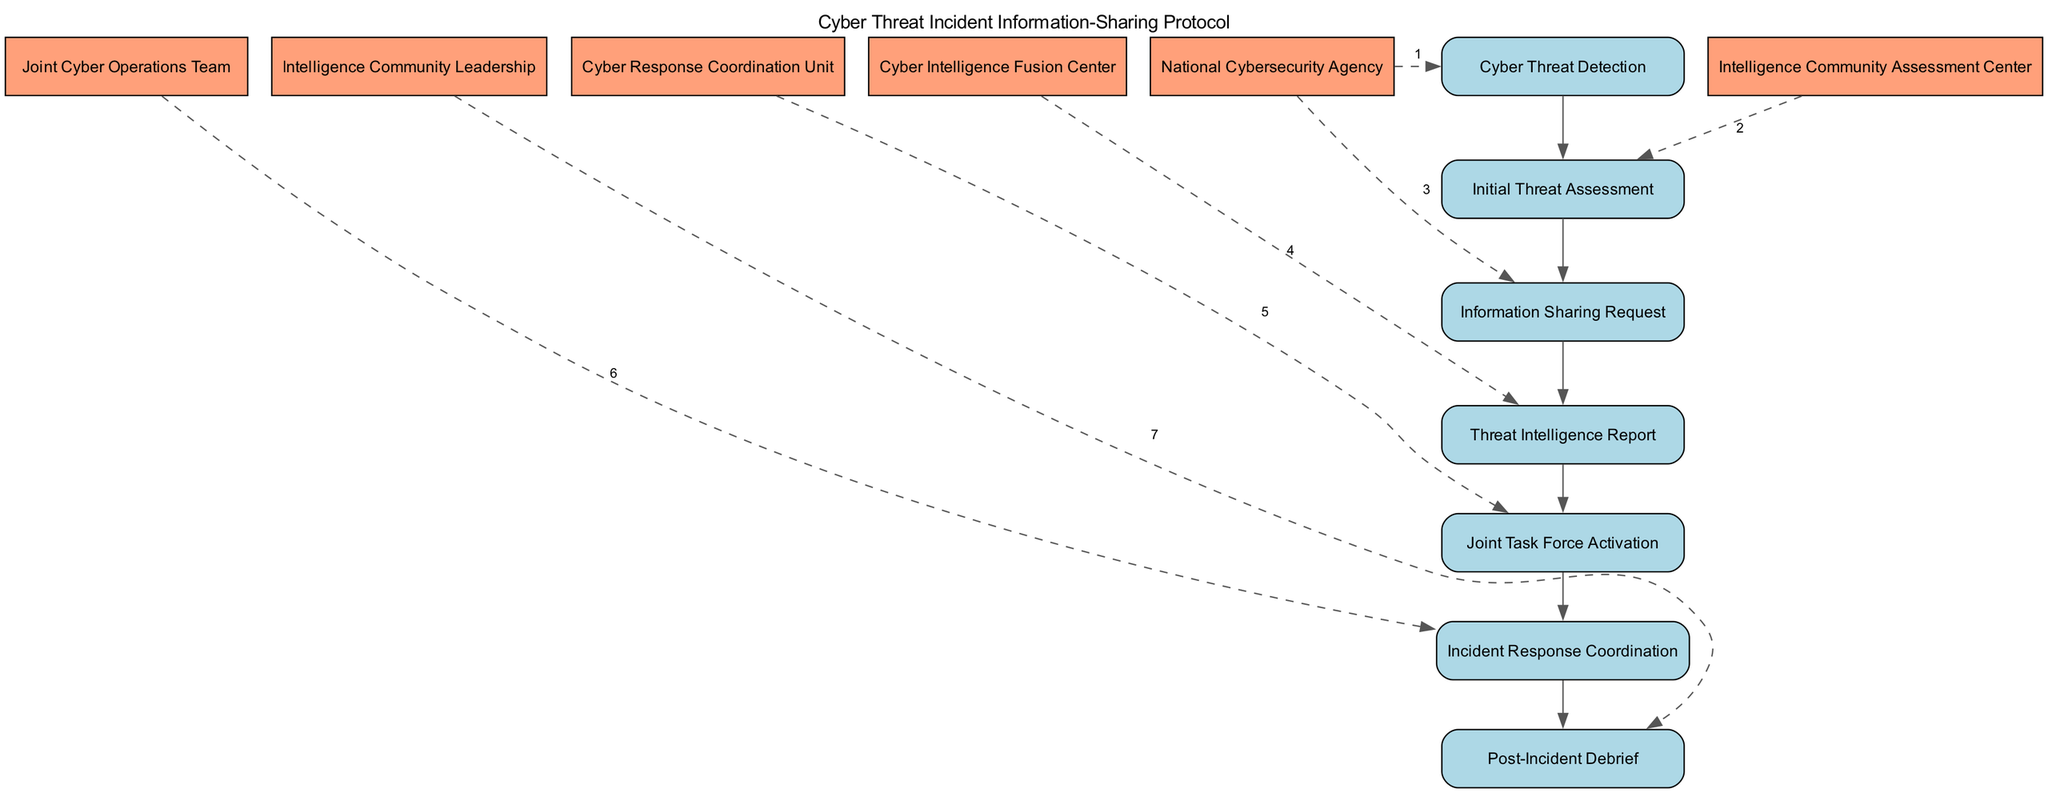What is the first step in the protocol? The first element listed in the sequence of events is "Cyber Threat Detection," which is the first step initiated by the National Cybersecurity Agency.
Answer: Cyber Threat Detection How many actors are represented in the diagram? By reviewing the unique entries for the 'actor' field in the elements, there are five distinct actors: National Cybersecurity Agency, Intelligence Community Assessment Center, Cyber Intelligence Fusion Center, Cyber Response Coordination Unit, and Joint Cyber Operations Team.
Answer: 5 What follows the "Information Sharing Request"? The flow of the diagram indicates that after the "Information Sharing Request," the next step is "Threat Intelligence Report." This can be inferred from the sequential connection between these two steps.
Answer: Threat Intelligence Report Which actor initiates the "Initial Threat Assessment"? The "Initial Threat Assessment" is conducted by the "Intelligence Community Assessment Center," thus making it clear that this actor is responsible for this step.
Answer: Intelligence Community Assessment Center What is the last step in the protocol? The final element of the sequence is "Post-Incident Debrief," indicating that this is the last step taken after the incident has been managed.
Answer: Post-Incident Debrief Which step indicates the formation of a collaborative task force? The step labeled "Joint Task Force Activation" represents the formation of a collaborative task force to address the incident, which is an essential aspect of the protocol.
Answer: Joint Task Force Activation In what order do the "Incident Response Coordination" and "Post-Incident Debrief" occur? The diagram shows that "Incident Response Coordination" happens before "Post-Incident Debrief," as it is part of the sequential flow of actions taken during the cyber threat incident.
Answer: Incident Response Coordination occurs before Post-Incident Debrief How many steps are involved in total? By counting the elements listed in the sequence, there are a total of seven steps involved in the protocol from the beginning to the end of the incident management process.
Answer: 7 